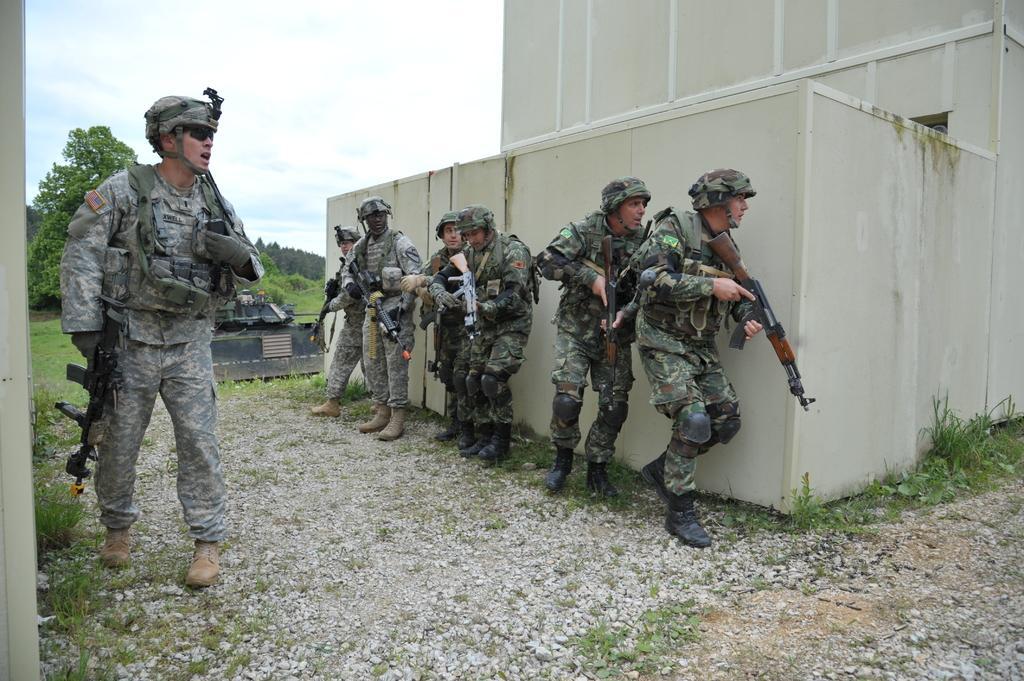How would you summarize this image in a sentence or two? In the picture we can see a path to it, we can see a grass plant and some building wall which is white in color and some army people standing and leaning to it, they are wearing a uniform and wearing helmets and holding a gun in their hands and opposite to them we can see another army person standing with a gun and in the background we can see some trees and sky with clouds. 